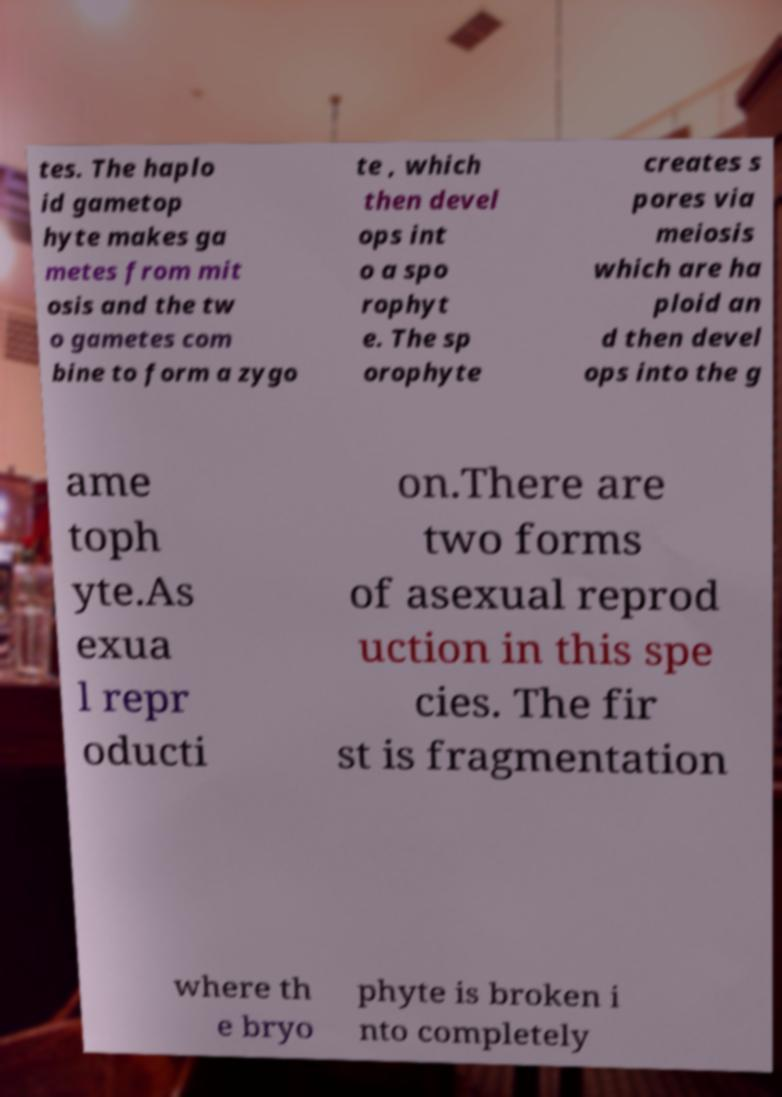Can you read and provide the text displayed in the image?This photo seems to have some interesting text. Can you extract and type it out for me? tes. The haplo id gametop hyte makes ga metes from mit osis and the tw o gametes com bine to form a zygo te , which then devel ops int o a spo rophyt e. The sp orophyte creates s pores via meiosis which are ha ploid an d then devel ops into the g ame toph yte.As exua l repr oducti on.There are two forms of asexual reprod uction in this spe cies. The fir st is fragmentation where th e bryo phyte is broken i nto completely 